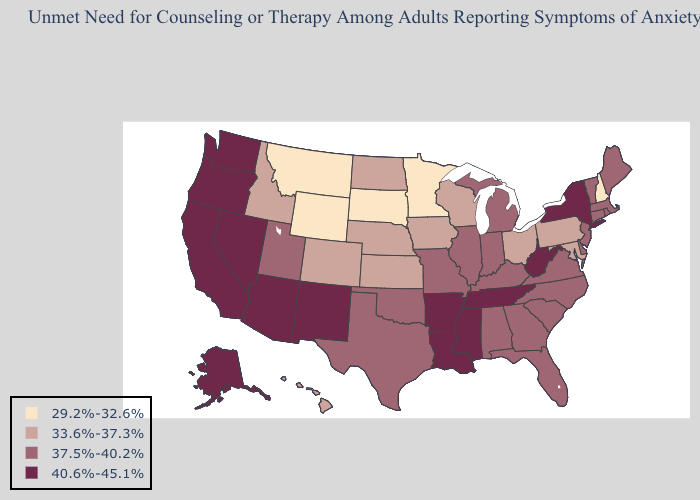Which states have the highest value in the USA?
Concise answer only. Alaska, Arizona, Arkansas, California, Louisiana, Mississippi, Nevada, New Mexico, New York, Oregon, Tennessee, Washington, West Virginia. Does Tennessee have a higher value than Mississippi?
Be succinct. No. What is the lowest value in the MidWest?
Be succinct. 29.2%-32.6%. What is the highest value in the USA?
Keep it brief. 40.6%-45.1%. Which states have the highest value in the USA?
Give a very brief answer. Alaska, Arizona, Arkansas, California, Louisiana, Mississippi, Nevada, New Mexico, New York, Oregon, Tennessee, Washington, West Virginia. Among the states that border Louisiana , does Arkansas have the highest value?
Short answer required. Yes. What is the highest value in states that border Kentucky?
Quick response, please. 40.6%-45.1%. Does the map have missing data?
Quick response, please. No. Name the states that have a value in the range 29.2%-32.6%?
Concise answer only. Minnesota, Montana, New Hampshire, South Dakota, Wyoming. What is the lowest value in the Northeast?
Quick response, please. 29.2%-32.6%. What is the value of Nebraska?
Short answer required. 33.6%-37.3%. Name the states that have a value in the range 33.6%-37.3%?
Keep it brief. Colorado, Hawaii, Idaho, Iowa, Kansas, Maryland, Nebraska, North Dakota, Ohio, Pennsylvania, Wisconsin. What is the highest value in the USA?
Write a very short answer. 40.6%-45.1%. Name the states that have a value in the range 37.5%-40.2%?
Short answer required. Alabama, Connecticut, Delaware, Florida, Georgia, Illinois, Indiana, Kentucky, Maine, Massachusetts, Michigan, Missouri, New Jersey, North Carolina, Oklahoma, Rhode Island, South Carolina, Texas, Utah, Vermont, Virginia. 